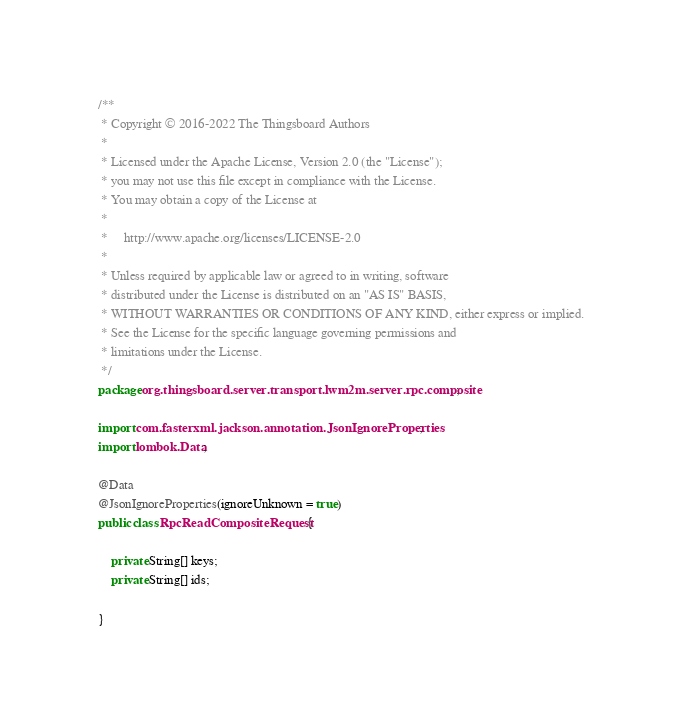Convert code to text. <code><loc_0><loc_0><loc_500><loc_500><_Java_>/**
 * Copyright © 2016-2022 The Thingsboard Authors
 *
 * Licensed under the Apache License, Version 2.0 (the "License");
 * you may not use this file except in compliance with the License.
 * You may obtain a copy of the License at
 *
 *     http://www.apache.org/licenses/LICENSE-2.0
 *
 * Unless required by applicable law or agreed to in writing, software
 * distributed under the License is distributed on an "AS IS" BASIS,
 * WITHOUT WARRANTIES OR CONDITIONS OF ANY KIND, either express or implied.
 * See the License for the specific language governing permissions and
 * limitations under the License.
 */
package org.thingsboard.server.transport.lwm2m.server.rpc.composite;

import com.fasterxml.jackson.annotation.JsonIgnoreProperties;
import lombok.Data;

@Data
@JsonIgnoreProperties(ignoreUnknown = true)
public class RpcReadCompositeRequest {

    private String[] keys;
    private String[] ids;

}
</code> 